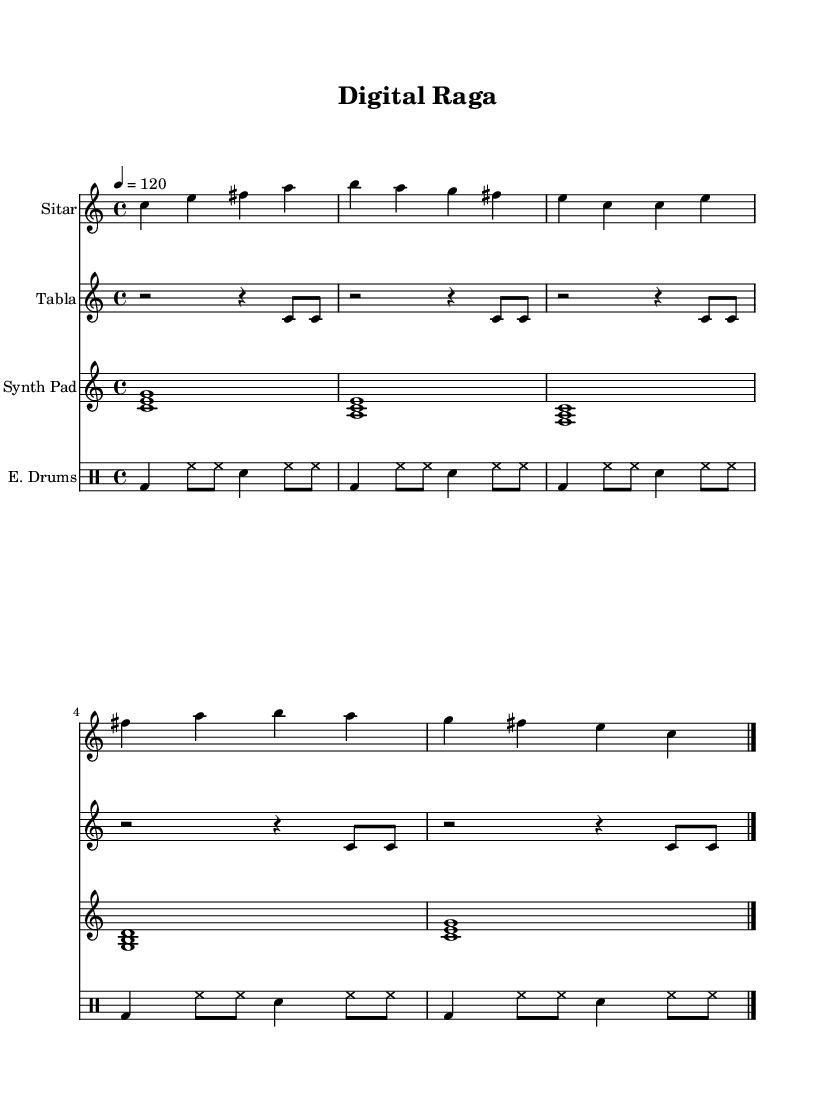What is the key signature of this music? The key signature is C major, which has no sharps or flats, as indicated at the beginning of the staff notation.
Answer: C major What is the time signature of this music? The time signature is 4/4, which is displayed at the beginning of the sheet music and indicates four beats per measure.
Answer: 4/4 What is the tempo marking for this piece? The tempo marking indicates a speed of 120 beats per minute as shown on the score.
Answer: 120 How many measures are in the Sitar part? The Sitar part consists of five measures, which can be counted on the score from start to end before the final bar line.
Answer: 5 Which instruments are included in this score? The instruments included in the score are Sitar, Tabla, Synth Pad, and Electronic Drums, as indicated by their respective staff names at the beginning of each part.
Answer: Sitar, Tabla, Synth Pad, Electronic Drums What type of music genre does this score represent? This composition is an exploration of Indian classical music blended with electronic elements, as suggested by the use of traditional instruments like the Sitar and Tabla alongside electronic sounds.
Answer: World Music 